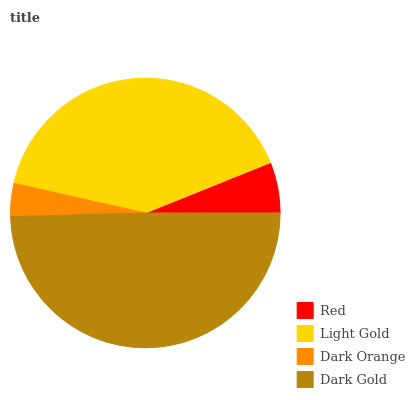Is Dark Orange the minimum?
Answer yes or no. Yes. Is Dark Gold the maximum?
Answer yes or no. Yes. Is Light Gold the minimum?
Answer yes or no. No. Is Light Gold the maximum?
Answer yes or no. No. Is Light Gold greater than Red?
Answer yes or no. Yes. Is Red less than Light Gold?
Answer yes or no. Yes. Is Red greater than Light Gold?
Answer yes or no. No. Is Light Gold less than Red?
Answer yes or no. No. Is Light Gold the high median?
Answer yes or no. Yes. Is Red the low median?
Answer yes or no. Yes. Is Dark Orange the high median?
Answer yes or no. No. Is Light Gold the low median?
Answer yes or no. No. 